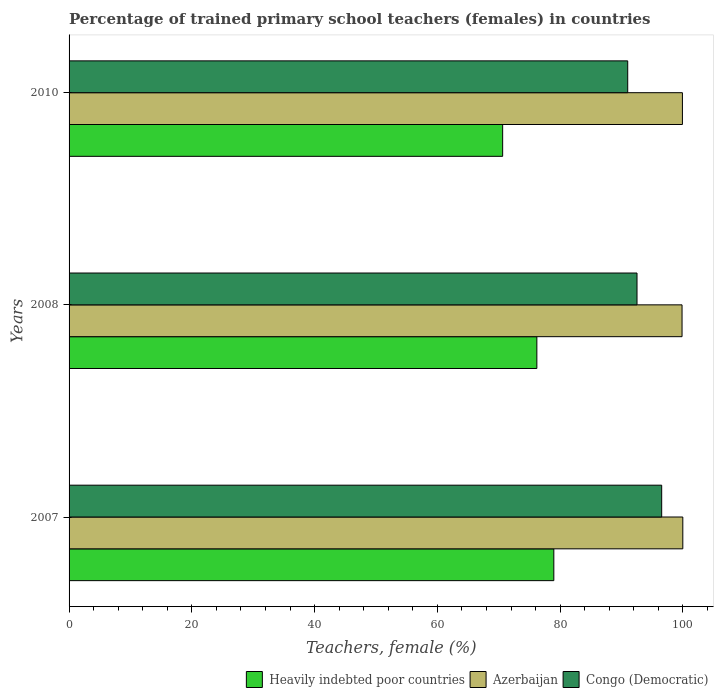How many different coloured bars are there?
Make the answer very short. 3. Are the number of bars per tick equal to the number of legend labels?
Your answer should be compact. Yes. How many bars are there on the 1st tick from the top?
Provide a short and direct response. 3. How many bars are there on the 3rd tick from the bottom?
Give a very brief answer. 3. In how many cases, is the number of bars for a given year not equal to the number of legend labels?
Your answer should be compact. 0. What is the percentage of trained primary school teachers (females) in Azerbaijan in 2010?
Offer a terse response. 99.92. Across all years, what is the maximum percentage of trained primary school teachers (females) in Azerbaijan?
Provide a short and direct response. 99.98. Across all years, what is the minimum percentage of trained primary school teachers (females) in Heavily indebted poor countries?
Your answer should be very brief. 70.64. In which year was the percentage of trained primary school teachers (females) in Heavily indebted poor countries maximum?
Ensure brevity in your answer.  2007. What is the total percentage of trained primary school teachers (females) in Congo (Democratic) in the graph?
Provide a succinct answer. 280.07. What is the difference between the percentage of trained primary school teachers (females) in Heavily indebted poor countries in 2007 and that in 2008?
Offer a terse response. 2.76. What is the difference between the percentage of trained primary school teachers (females) in Heavily indebted poor countries in 2008 and the percentage of trained primary school teachers (females) in Congo (Democratic) in 2007?
Offer a terse response. -20.34. What is the average percentage of trained primary school teachers (females) in Heavily indebted poor countries per year?
Offer a terse response. 75.27. In the year 2008, what is the difference between the percentage of trained primary school teachers (females) in Congo (Democratic) and percentage of trained primary school teachers (females) in Heavily indebted poor countries?
Keep it short and to the point. 16.32. In how many years, is the percentage of trained primary school teachers (females) in Heavily indebted poor countries greater than 92 %?
Ensure brevity in your answer.  0. What is the ratio of the percentage of trained primary school teachers (females) in Azerbaijan in 2008 to that in 2010?
Make the answer very short. 1. Is the percentage of trained primary school teachers (females) in Congo (Democratic) in 2007 less than that in 2008?
Ensure brevity in your answer.  No. Is the difference between the percentage of trained primary school teachers (females) in Congo (Democratic) in 2007 and 2010 greater than the difference between the percentage of trained primary school teachers (females) in Heavily indebted poor countries in 2007 and 2010?
Provide a short and direct response. No. What is the difference between the highest and the second highest percentage of trained primary school teachers (females) in Azerbaijan?
Your response must be concise. 0.06. What is the difference between the highest and the lowest percentage of trained primary school teachers (females) in Heavily indebted poor countries?
Offer a terse response. 8.34. Is the sum of the percentage of trained primary school teachers (females) in Congo (Democratic) in 2007 and 2010 greater than the maximum percentage of trained primary school teachers (females) in Heavily indebted poor countries across all years?
Keep it short and to the point. Yes. What does the 2nd bar from the top in 2007 represents?
Your answer should be very brief. Azerbaijan. What does the 2nd bar from the bottom in 2008 represents?
Give a very brief answer. Azerbaijan. Is it the case that in every year, the sum of the percentage of trained primary school teachers (females) in Azerbaijan and percentage of trained primary school teachers (females) in Congo (Democratic) is greater than the percentage of trained primary school teachers (females) in Heavily indebted poor countries?
Ensure brevity in your answer.  Yes. How many bars are there?
Give a very brief answer. 9. Are all the bars in the graph horizontal?
Keep it short and to the point. Yes. Does the graph contain grids?
Offer a very short reply. No. How are the legend labels stacked?
Ensure brevity in your answer.  Horizontal. What is the title of the graph?
Give a very brief answer. Percentage of trained primary school teachers (females) in countries. What is the label or title of the X-axis?
Offer a terse response. Teachers, female (%). What is the Teachers, female (%) of Heavily indebted poor countries in 2007?
Your answer should be very brief. 78.97. What is the Teachers, female (%) of Azerbaijan in 2007?
Your answer should be compact. 99.98. What is the Teachers, female (%) in Congo (Democratic) in 2007?
Give a very brief answer. 96.54. What is the Teachers, female (%) of Heavily indebted poor countries in 2008?
Your response must be concise. 76.21. What is the Teachers, female (%) in Azerbaijan in 2008?
Your answer should be compact. 99.86. What is the Teachers, female (%) of Congo (Democratic) in 2008?
Offer a very short reply. 92.52. What is the Teachers, female (%) in Heavily indebted poor countries in 2010?
Make the answer very short. 70.64. What is the Teachers, female (%) of Azerbaijan in 2010?
Ensure brevity in your answer.  99.92. What is the Teachers, female (%) in Congo (Democratic) in 2010?
Make the answer very short. 91.01. Across all years, what is the maximum Teachers, female (%) in Heavily indebted poor countries?
Ensure brevity in your answer.  78.97. Across all years, what is the maximum Teachers, female (%) of Azerbaijan?
Ensure brevity in your answer.  99.98. Across all years, what is the maximum Teachers, female (%) in Congo (Democratic)?
Your answer should be compact. 96.54. Across all years, what is the minimum Teachers, female (%) in Heavily indebted poor countries?
Keep it short and to the point. 70.64. Across all years, what is the minimum Teachers, female (%) in Azerbaijan?
Your answer should be compact. 99.86. Across all years, what is the minimum Teachers, female (%) in Congo (Democratic)?
Offer a terse response. 91.01. What is the total Teachers, female (%) of Heavily indebted poor countries in the graph?
Provide a succinct answer. 225.81. What is the total Teachers, female (%) of Azerbaijan in the graph?
Keep it short and to the point. 299.76. What is the total Teachers, female (%) in Congo (Democratic) in the graph?
Give a very brief answer. 280.07. What is the difference between the Teachers, female (%) in Heavily indebted poor countries in 2007 and that in 2008?
Your response must be concise. 2.76. What is the difference between the Teachers, female (%) in Azerbaijan in 2007 and that in 2008?
Make the answer very short. 0.12. What is the difference between the Teachers, female (%) of Congo (Democratic) in 2007 and that in 2008?
Make the answer very short. 4.02. What is the difference between the Teachers, female (%) of Heavily indebted poor countries in 2007 and that in 2010?
Offer a very short reply. 8.34. What is the difference between the Teachers, female (%) of Azerbaijan in 2007 and that in 2010?
Provide a short and direct response. 0.06. What is the difference between the Teachers, female (%) in Congo (Democratic) in 2007 and that in 2010?
Your answer should be very brief. 5.54. What is the difference between the Teachers, female (%) in Heavily indebted poor countries in 2008 and that in 2010?
Give a very brief answer. 5.57. What is the difference between the Teachers, female (%) of Azerbaijan in 2008 and that in 2010?
Offer a very short reply. -0.06. What is the difference between the Teachers, female (%) in Congo (Democratic) in 2008 and that in 2010?
Ensure brevity in your answer.  1.51. What is the difference between the Teachers, female (%) in Heavily indebted poor countries in 2007 and the Teachers, female (%) in Azerbaijan in 2008?
Give a very brief answer. -20.89. What is the difference between the Teachers, female (%) of Heavily indebted poor countries in 2007 and the Teachers, female (%) of Congo (Democratic) in 2008?
Keep it short and to the point. -13.55. What is the difference between the Teachers, female (%) in Azerbaijan in 2007 and the Teachers, female (%) in Congo (Democratic) in 2008?
Your answer should be compact. 7.46. What is the difference between the Teachers, female (%) in Heavily indebted poor countries in 2007 and the Teachers, female (%) in Azerbaijan in 2010?
Your response must be concise. -20.95. What is the difference between the Teachers, female (%) of Heavily indebted poor countries in 2007 and the Teachers, female (%) of Congo (Democratic) in 2010?
Keep it short and to the point. -12.04. What is the difference between the Teachers, female (%) in Azerbaijan in 2007 and the Teachers, female (%) in Congo (Democratic) in 2010?
Your answer should be very brief. 8.97. What is the difference between the Teachers, female (%) in Heavily indebted poor countries in 2008 and the Teachers, female (%) in Azerbaijan in 2010?
Make the answer very short. -23.71. What is the difference between the Teachers, female (%) in Heavily indebted poor countries in 2008 and the Teachers, female (%) in Congo (Democratic) in 2010?
Keep it short and to the point. -14.8. What is the difference between the Teachers, female (%) in Azerbaijan in 2008 and the Teachers, female (%) in Congo (Democratic) in 2010?
Make the answer very short. 8.85. What is the average Teachers, female (%) of Heavily indebted poor countries per year?
Your answer should be compact. 75.27. What is the average Teachers, female (%) in Azerbaijan per year?
Provide a succinct answer. 99.92. What is the average Teachers, female (%) in Congo (Democratic) per year?
Your response must be concise. 93.36. In the year 2007, what is the difference between the Teachers, female (%) of Heavily indebted poor countries and Teachers, female (%) of Azerbaijan?
Keep it short and to the point. -21.01. In the year 2007, what is the difference between the Teachers, female (%) of Heavily indebted poor countries and Teachers, female (%) of Congo (Democratic)?
Keep it short and to the point. -17.57. In the year 2007, what is the difference between the Teachers, female (%) of Azerbaijan and Teachers, female (%) of Congo (Democratic)?
Make the answer very short. 3.44. In the year 2008, what is the difference between the Teachers, female (%) in Heavily indebted poor countries and Teachers, female (%) in Azerbaijan?
Keep it short and to the point. -23.65. In the year 2008, what is the difference between the Teachers, female (%) of Heavily indebted poor countries and Teachers, female (%) of Congo (Democratic)?
Provide a succinct answer. -16.32. In the year 2008, what is the difference between the Teachers, female (%) of Azerbaijan and Teachers, female (%) of Congo (Democratic)?
Offer a very short reply. 7.34. In the year 2010, what is the difference between the Teachers, female (%) in Heavily indebted poor countries and Teachers, female (%) in Azerbaijan?
Offer a very short reply. -29.29. In the year 2010, what is the difference between the Teachers, female (%) of Heavily indebted poor countries and Teachers, female (%) of Congo (Democratic)?
Give a very brief answer. -20.37. In the year 2010, what is the difference between the Teachers, female (%) of Azerbaijan and Teachers, female (%) of Congo (Democratic)?
Give a very brief answer. 8.91. What is the ratio of the Teachers, female (%) of Heavily indebted poor countries in 2007 to that in 2008?
Provide a succinct answer. 1.04. What is the ratio of the Teachers, female (%) in Congo (Democratic) in 2007 to that in 2008?
Ensure brevity in your answer.  1.04. What is the ratio of the Teachers, female (%) in Heavily indebted poor countries in 2007 to that in 2010?
Your answer should be very brief. 1.12. What is the ratio of the Teachers, female (%) of Azerbaijan in 2007 to that in 2010?
Give a very brief answer. 1. What is the ratio of the Teachers, female (%) in Congo (Democratic) in 2007 to that in 2010?
Your response must be concise. 1.06. What is the ratio of the Teachers, female (%) of Heavily indebted poor countries in 2008 to that in 2010?
Your answer should be very brief. 1.08. What is the ratio of the Teachers, female (%) of Azerbaijan in 2008 to that in 2010?
Keep it short and to the point. 1. What is the ratio of the Teachers, female (%) of Congo (Democratic) in 2008 to that in 2010?
Offer a terse response. 1.02. What is the difference between the highest and the second highest Teachers, female (%) in Heavily indebted poor countries?
Provide a succinct answer. 2.76. What is the difference between the highest and the second highest Teachers, female (%) of Azerbaijan?
Your answer should be very brief. 0.06. What is the difference between the highest and the second highest Teachers, female (%) of Congo (Democratic)?
Provide a short and direct response. 4.02. What is the difference between the highest and the lowest Teachers, female (%) of Heavily indebted poor countries?
Provide a succinct answer. 8.34. What is the difference between the highest and the lowest Teachers, female (%) of Azerbaijan?
Make the answer very short. 0.12. What is the difference between the highest and the lowest Teachers, female (%) of Congo (Democratic)?
Offer a very short reply. 5.54. 